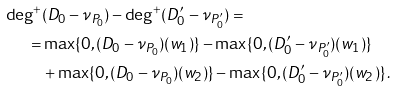Convert formula to latex. <formula><loc_0><loc_0><loc_500><loc_500>\deg ^ { + } & ( D _ { 0 } - \nu _ { P _ { 0 } } ) - \deg ^ { + } ( D ^ { \prime } _ { 0 } - \nu _ { P ^ { \prime } _ { 0 } } ) = \\ = & \max \{ 0 , ( D _ { 0 } - \nu _ { P _ { 0 } } ) ( w _ { 1 } ) \} - \max \{ 0 , ( D ^ { \prime } _ { 0 } - \nu _ { P ^ { \prime } _ { 0 } } ) ( w _ { 1 } ) \} \\ & + \max \{ 0 , ( D _ { 0 } - \nu _ { P _ { 0 } } ) ( w _ { 2 } ) \} - \max \{ 0 , ( D ^ { \prime } _ { 0 } - \nu _ { P ^ { \prime } _ { 0 } } ) ( w _ { 2 } ) \} \, .</formula> 